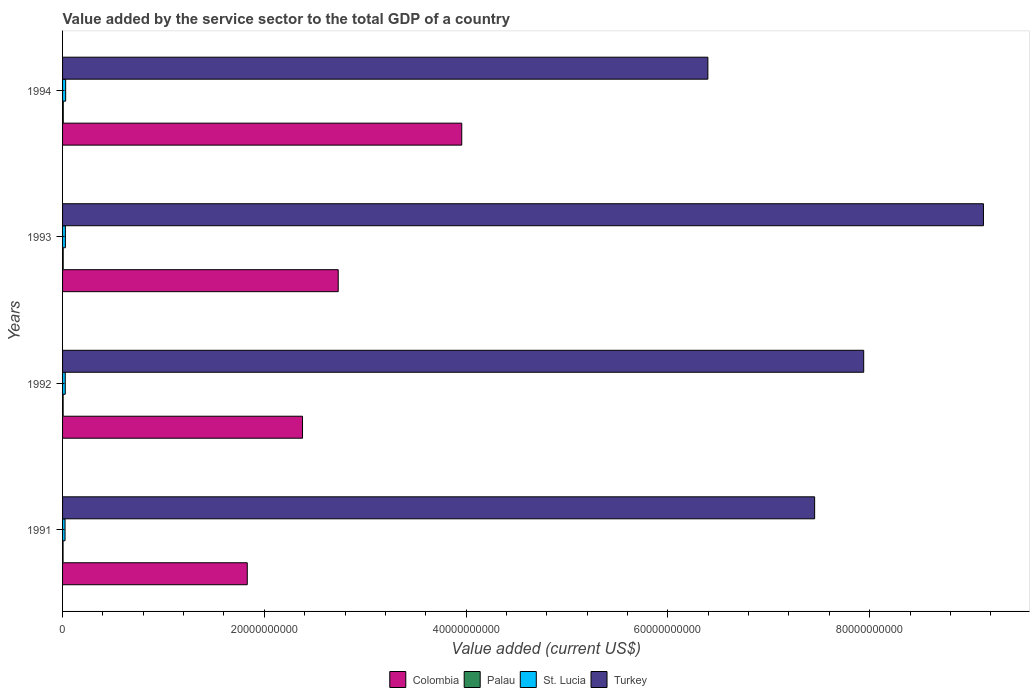How many different coloured bars are there?
Ensure brevity in your answer.  4. Are the number of bars on each tick of the Y-axis equal?
Give a very brief answer. Yes. How many bars are there on the 3rd tick from the bottom?
Ensure brevity in your answer.  4. What is the label of the 4th group of bars from the top?
Ensure brevity in your answer.  1991. What is the value added by the service sector to the total GDP in Palau in 1992?
Offer a terse response. 5.68e+07. Across all years, what is the maximum value added by the service sector to the total GDP in St. Lucia?
Provide a succinct answer. 3.07e+08. Across all years, what is the minimum value added by the service sector to the total GDP in Colombia?
Your response must be concise. 1.83e+1. In which year was the value added by the service sector to the total GDP in Turkey maximum?
Offer a very short reply. 1993. In which year was the value added by the service sector to the total GDP in Palau minimum?
Offer a terse response. 1991. What is the total value added by the service sector to the total GDP in St. Lucia in the graph?
Give a very brief answer. 1.10e+09. What is the difference between the value added by the service sector to the total GDP in Colombia in 1991 and that in 1992?
Your answer should be compact. -5.48e+09. What is the difference between the value added by the service sector to the total GDP in St. Lucia in 1992 and the value added by the service sector to the total GDP in Palau in 1991?
Offer a very short reply. 2.19e+08. What is the average value added by the service sector to the total GDP in Palau per year?
Give a very brief answer. 5.89e+07. In the year 1992, what is the difference between the value added by the service sector to the total GDP in Palau and value added by the service sector to the total GDP in St. Lucia?
Your response must be concise. -2.11e+08. In how many years, is the value added by the service sector to the total GDP in Colombia greater than 20000000000 US$?
Offer a very short reply. 3. What is the ratio of the value added by the service sector to the total GDP in Colombia in 1992 to that in 1994?
Offer a very short reply. 0.6. Is the difference between the value added by the service sector to the total GDP in Palau in 1992 and 1993 greater than the difference between the value added by the service sector to the total GDP in St. Lucia in 1992 and 1993?
Your answer should be compact. Yes. What is the difference between the highest and the second highest value added by the service sector to the total GDP in St. Lucia?
Your answer should be very brief. 2.66e+07. What is the difference between the highest and the lowest value added by the service sector to the total GDP in Turkey?
Provide a short and direct response. 2.73e+1. Is it the case that in every year, the sum of the value added by the service sector to the total GDP in Colombia and value added by the service sector to the total GDP in Palau is greater than the sum of value added by the service sector to the total GDP in St. Lucia and value added by the service sector to the total GDP in Turkey?
Offer a very short reply. Yes. What does the 1st bar from the top in 1994 represents?
Your answer should be very brief. Turkey. What does the 2nd bar from the bottom in 1991 represents?
Keep it short and to the point. Palau. Is it the case that in every year, the sum of the value added by the service sector to the total GDP in St. Lucia and value added by the service sector to the total GDP in Colombia is greater than the value added by the service sector to the total GDP in Turkey?
Make the answer very short. No. Are all the bars in the graph horizontal?
Your response must be concise. Yes. What is the difference between two consecutive major ticks on the X-axis?
Provide a short and direct response. 2.00e+1. Are the values on the major ticks of X-axis written in scientific E-notation?
Offer a very short reply. No. Does the graph contain any zero values?
Provide a short and direct response. No. Where does the legend appear in the graph?
Provide a succinct answer. Bottom center. How many legend labels are there?
Give a very brief answer. 4. What is the title of the graph?
Keep it short and to the point. Value added by the service sector to the total GDP of a country. Does "Iran" appear as one of the legend labels in the graph?
Your answer should be very brief. No. What is the label or title of the X-axis?
Offer a very short reply. Value added (current US$). What is the Value added (current US$) in Colombia in 1991?
Offer a terse response. 1.83e+1. What is the Value added (current US$) of Palau in 1991?
Your response must be concise. 4.89e+07. What is the Value added (current US$) of St. Lucia in 1991?
Your answer should be very brief. 2.46e+08. What is the Value added (current US$) of Turkey in 1991?
Give a very brief answer. 7.45e+1. What is the Value added (current US$) of Colombia in 1992?
Your answer should be very brief. 2.38e+1. What is the Value added (current US$) in Palau in 1992?
Your response must be concise. 5.68e+07. What is the Value added (current US$) of St. Lucia in 1992?
Provide a succinct answer. 2.68e+08. What is the Value added (current US$) in Turkey in 1992?
Provide a succinct answer. 7.94e+1. What is the Value added (current US$) of Colombia in 1993?
Your answer should be compact. 2.73e+1. What is the Value added (current US$) in Palau in 1993?
Keep it short and to the point. 6.12e+07. What is the Value added (current US$) of St. Lucia in 1993?
Your response must be concise. 2.80e+08. What is the Value added (current US$) in Turkey in 1993?
Provide a succinct answer. 9.13e+1. What is the Value added (current US$) of Colombia in 1994?
Make the answer very short. 3.96e+1. What is the Value added (current US$) of Palau in 1994?
Offer a very short reply. 6.86e+07. What is the Value added (current US$) of St. Lucia in 1994?
Your answer should be very brief. 3.07e+08. What is the Value added (current US$) of Turkey in 1994?
Provide a short and direct response. 6.40e+1. Across all years, what is the maximum Value added (current US$) of Colombia?
Keep it short and to the point. 3.96e+1. Across all years, what is the maximum Value added (current US$) in Palau?
Your answer should be very brief. 6.86e+07. Across all years, what is the maximum Value added (current US$) of St. Lucia?
Give a very brief answer. 3.07e+08. Across all years, what is the maximum Value added (current US$) of Turkey?
Offer a terse response. 9.13e+1. Across all years, what is the minimum Value added (current US$) in Colombia?
Your answer should be very brief. 1.83e+1. Across all years, what is the minimum Value added (current US$) of Palau?
Provide a succinct answer. 4.89e+07. Across all years, what is the minimum Value added (current US$) of St. Lucia?
Provide a succinct answer. 2.46e+08. Across all years, what is the minimum Value added (current US$) in Turkey?
Offer a very short reply. 6.40e+1. What is the total Value added (current US$) of Colombia in the graph?
Provide a short and direct response. 1.09e+11. What is the total Value added (current US$) of Palau in the graph?
Offer a very short reply. 2.36e+08. What is the total Value added (current US$) in St. Lucia in the graph?
Offer a terse response. 1.10e+09. What is the total Value added (current US$) in Turkey in the graph?
Ensure brevity in your answer.  3.09e+11. What is the difference between the Value added (current US$) of Colombia in 1991 and that in 1992?
Offer a terse response. -5.48e+09. What is the difference between the Value added (current US$) of Palau in 1991 and that in 1992?
Make the answer very short. -7.90e+06. What is the difference between the Value added (current US$) in St. Lucia in 1991 and that in 1992?
Ensure brevity in your answer.  -2.15e+07. What is the difference between the Value added (current US$) of Turkey in 1991 and that in 1992?
Provide a succinct answer. -4.86e+09. What is the difference between the Value added (current US$) in Colombia in 1991 and that in 1993?
Make the answer very short. -9.01e+09. What is the difference between the Value added (current US$) in Palau in 1991 and that in 1993?
Offer a terse response. -1.23e+07. What is the difference between the Value added (current US$) of St. Lucia in 1991 and that in 1993?
Your answer should be very brief. -3.39e+07. What is the difference between the Value added (current US$) in Turkey in 1991 and that in 1993?
Make the answer very short. -1.67e+1. What is the difference between the Value added (current US$) in Colombia in 1991 and that in 1994?
Keep it short and to the point. -2.13e+1. What is the difference between the Value added (current US$) of Palau in 1991 and that in 1994?
Make the answer very short. -1.97e+07. What is the difference between the Value added (current US$) in St. Lucia in 1991 and that in 1994?
Make the answer very short. -6.05e+07. What is the difference between the Value added (current US$) of Turkey in 1991 and that in 1994?
Give a very brief answer. 1.06e+1. What is the difference between the Value added (current US$) of Colombia in 1992 and that in 1993?
Provide a short and direct response. -3.54e+09. What is the difference between the Value added (current US$) in Palau in 1992 and that in 1993?
Provide a short and direct response. -4.41e+06. What is the difference between the Value added (current US$) in St. Lucia in 1992 and that in 1993?
Keep it short and to the point. -1.24e+07. What is the difference between the Value added (current US$) in Turkey in 1992 and that in 1993?
Keep it short and to the point. -1.19e+1. What is the difference between the Value added (current US$) in Colombia in 1992 and that in 1994?
Your response must be concise. -1.58e+1. What is the difference between the Value added (current US$) of Palau in 1992 and that in 1994?
Your response must be concise. -1.18e+07. What is the difference between the Value added (current US$) in St. Lucia in 1992 and that in 1994?
Your answer should be very brief. -3.90e+07. What is the difference between the Value added (current US$) of Turkey in 1992 and that in 1994?
Provide a short and direct response. 1.54e+1. What is the difference between the Value added (current US$) in Colombia in 1993 and that in 1994?
Offer a terse response. -1.22e+1. What is the difference between the Value added (current US$) of Palau in 1993 and that in 1994?
Keep it short and to the point. -7.42e+06. What is the difference between the Value added (current US$) of St. Lucia in 1993 and that in 1994?
Keep it short and to the point. -2.66e+07. What is the difference between the Value added (current US$) in Turkey in 1993 and that in 1994?
Offer a very short reply. 2.73e+1. What is the difference between the Value added (current US$) in Colombia in 1991 and the Value added (current US$) in Palau in 1992?
Your answer should be very brief. 1.83e+1. What is the difference between the Value added (current US$) in Colombia in 1991 and the Value added (current US$) in St. Lucia in 1992?
Your answer should be compact. 1.80e+1. What is the difference between the Value added (current US$) of Colombia in 1991 and the Value added (current US$) of Turkey in 1992?
Your response must be concise. -6.11e+1. What is the difference between the Value added (current US$) of Palau in 1991 and the Value added (current US$) of St. Lucia in 1992?
Make the answer very short. -2.19e+08. What is the difference between the Value added (current US$) of Palau in 1991 and the Value added (current US$) of Turkey in 1992?
Offer a very short reply. -7.94e+1. What is the difference between the Value added (current US$) of St. Lucia in 1991 and the Value added (current US$) of Turkey in 1992?
Your answer should be very brief. -7.92e+1. What is the difference between the Value added (current US$) in Colombia in 1991 and the Value added (current US$) in Palau in 1993?
Offer a terse response. 1.82e+1. What is the difference between the Value added (current US$) in Colombia in 1991 and the Value added (current US$) in St. Lucia in 1993?
Provide a short and direct response. 1.80e+1. What is the difference between the Value added (current US$) of Colombia in 1991 and the Value added (current US$) of Turkey in 1993?
Your answer should be compact. -7.30e+1. What is the difference between the Value added (current US$) in Palau in 1991 and the Value added (current US$) in St. Lucia in 1993?
Provide a short and direct response. -2.31e+08. What is the difference between the Value added (current US$) in Palau in 1991 and the Value added (current US$) in Turkey in 1993?
Your response must be concise. -9.12e+1. What is the difference between the Value added (current US$) in St. Lucia in 1991 and the Value added (current US$) in Turkey in 1993?
Your answer should be very brief. -9.10e+1. What is the difference between the Value added (current US$) in Colombia in 1991 and the Value added (current US$) in Palau in 1994?
Provide a short and direct response. 1.82e+1. What is the difference between the Value added (current US$) of Colombia in 1991 and the Value added (current US$) of St. Lucia in 1994?
Provide a succinct answer. 1.80e+1. What is the difference between the Value added (current US$) in Colombia in 1991 and the Value added (current US$) in Turkey in 1994?
Keep it short and to the point. -4.57e+1. What is the difference between the Value added (current US$) in Palau in 1991 and the Value added (current US$) in St. Lucia in 1994?
Ensure brevity in your answer.  -2.58e+08. What is the difference between the Value added (current US$) in Palau in 1991 and the Value added (current US$) in Turkey in 1994?
Provide a succinct answer. -6.39e+1. What is the difference between the Value added (current US$) of St. Lucia in 1991 and the Value added (current US$) of Turkey in 1994?
Offer a terse response. -6.37e+1. What is the difference between the Value added (current US$) of Colombia in 1992 and the Value added (current US$) of Palau in 1993?
Offer a very short reply. 2.37e+1. What is the difference between the Value added (current US$) in Colombia in 1992 and the Value added (current US$) in St. Lucia in 1993?
Ensure brevity in your answer.  2.35e+1. What is the difference between the Value added (current US$) of Colombia in 1992 and the Value added (current US$) of Turkey in 1993?
Give a very brief answer. -6.75e+1. What is the difference between the Value added (current US$) in Palau in 1992 and the Value added (current US$) in St. Lucia in 1993?
Make the answer very short. -2.23e+08. What is the difference between the Value added (current US$) in Palau in 1992 and the Value added (current US$) in Turkey in 1993?
Ensure brevity in your answer.  -9.12e+1. What is the difference between the Value added (current US$) of St. Lucia in 1992 and the Value added (current US$) of Turkey in 1993?
Provide a succinct answer. -9.10e+1. What is the difference between the Value added (current US$) in Colombia in 1992 and the Value added (current US$) in Palau in 1994?
Provide a short and direct response. 2.37e+1. What is the difference between the Value added (current US$) of Colombia in 1992 and the Value added (current US$) of St. Lucia in 1994?
Keep it short and to the point. 2.35e+1. What is the difference between the Value added (current US$) of Colombia in 1992 and the Value added (current US$) of Turkey in 1994?
Keep it short and to the point. -4.02e+1. What is the difference between the Value added (current US$) of Palau in 1992 and the Value added (current US$) of St. Lucia in 1994?
Keep it short and to the point. -2.50e+08. What is the difference between the Value added (current US$) of Palau in 1992 and the Value added (current US$) of Turkey in 1994?
Offer a very short reply. -6.39e+1. What is the difference between the Value added (current US$) in St. Lucia in 1992 and the Value added (current US$) in Turkey in 1994?
Provide a succinct answer. -6.37e+1. What is the difference between the Value added (current US$) in Colombia in 1993 and the Value added (current US$) in Palau in 1994?
Offer a terse response. 2.73e+1. What is the difference between the Value added (current US$) in Colombia in 1993 and the Value added (current US$) in St. Lucia in 1994?
Your response must be concise. 2.70e+1. What is the difference between the Value added (current US$) of Colombia in 1993 and the Value added (current US$) of Turkey in 1994?
Make the answer very short. -3.66e+1. What is the difference between the Value added (current US$) of Palau in 1993 and the Value added (current US$) of St. Lucia in 1994?
Your answer should be very brief. -2.45e+08. What is the difference between the Value added (current US$) of Palau in 1993 and the Value added (current US$) of Turkey in 1994?
Make the answer very short. -6.39e+1. What is the difference between the Value added (current US$) in St. Lucia in 1993 and the Value added (current US$) in Turkey in 1994?
Keep it short and to the point. -6.37e+1. What is the average Value added (current US$) of Colombia per year?
Offer a very short reply. 2.72e+1. What is the average Value added (current US$) of Palau per year?
Your response must be concise. 5.89e+07. What is the average Value added (current US$) of St. Lucia per year?
Ensure brevity in your answer.  2.75e+08. What is the average Value added (current US$) in Turkey per year?
Provide a short and direct response. 7.73e+1. In the year 1991, what is the difference between the Value added (current US$) in Colombia and Value added (current US$) in Palau?
Provide a succinct answer. 1.83e+1. In the year 1991, what is the difference between the Value added (current US$) of Colombia and Value added (current US$) of St. Lucia?
Your answer should be very brief. 1.81e+1. In the year 1991, what is the difference between the Value added (current US$) in Colombia and Value added (current US$) in Turkey?
Give a very brief answer. -5.62e+1. In the year 1991, what is the difference between the Value added (current US$) of Palau and Value added (current US$) of St. Lucia?
Provide a short and direct response. -1.97e+08. In the year 1991, what is the difference between the Value added (current US$) in Palau and Value added (current US$) in Turkey?
Your response must be concise. -7.45e+1. In the year 1991, what is the difference between the Value added (current US$) in St. Lucia and Value added (current US$) in Turkey?
Offer a terse response. -7.43e+1. In the year 1992, what is the difference between the Value added (current US$) in Colombia and Value added (current US$) in Palau?
Ensure brevity in your answer.  2.37e+1. In the year 1992, what is the difference between the Value added (current US$) in Colombia and Value added (current US$) in St. Lucia?
Give a very brief answer. 2.35e+1. In the year 1992, what is the difference between the Value added (current US$) of Colombia and Value added (current US$) of Turkey?
Your response must be concise. -5.56e+1. In the year 1992, what is the difference between the Value added (current US$) of Palau and Value added (current US$) of St. Lucia?
Offer a terse response. -2.11e+08. In the year 1992, what is the difference between the Value added (current US$) of Palau and Value added (current US$) of Turkey?
Provide a succinct answer. -7.94e+1. In the year 1992, what is the difference between the Value added (current US$) of St. Lucia and Value added (current US$) of Turkey?
Ensure brevity in your answer.  -7.91e+1. In the year 1993, what is the difference between the Value added (current US$) in Colombia and Value added (current US$) in Palau?
Make the answer very short. 2.73e+1. In the year 1993, what is the difference between the Value added (current US$) in Colombia and Value added (current US$) in St. Lucia?
Provide a succinct answer. 2.70e+1. In the year 1993, what is the difference between the Value added (current US$) of Colombia and Value added (current US$) of Turkey?
Your answer should be very brief. -6.40e+1. In the year 1993, what is the difference between the Value added (current US$) in Palau and Value added (current US$) in St. Lucia?
Ensure brevity in your answer.  -2.19e+08. In the year 1993, what is the difference between the Value added (current US$) in Palau and Value added (current US$) in Turkey?
Your answer should be very brief. -9.12e+1. In the year 1993, what is the difference between the Value added (current US$) in St. Lucia and Value added (current US$) in Turkey?
Your answer should be very brief. -9.10e+1. In the year 1994, what is the difference between the Value added (current US$) of Colombia and Value added (current US$) of Palau?
Keep it short and to the point. 3.95e+1. In the year 1994, what is the difference between the Value added (current US$) in Colombia and Value added (current US$) in St. Lucia?
Provide a succinct answer. 3.93e+1. In the year 1994, what is the difference between the Value added (current US$) of Colombia and Value added (current US$) of Turkey?
Make the answer very short. -2.44e+1. In the year 1994, what is the difference between the Value added (current US$) in Palau and Value added (current US$) in St. Lucia?
Offer a terse response. -2.38e+08. In the year 1994, what is the difference between the Value added (current US$) of Palau and Value added (current US$) of Turkey?
Your answer should be compact. -6.39e+1. In the year 1994, what is the difference between the Value added (current US$) of St. Lucia and Value added (current US$) of Turkey?
Offer a terse response. -6.37e+1. What is the ratio of the Value added (current US$) of Colombia in 1991 to that in 1992?
Offer a very short reply. 0.77. What is the ratio of the Value added (current US$) in Palau in 1991 to that in 1992?
Give a very brief answer. 0.86. What is the ratio of the Value added (current US$) of St. Lucia in 1991 to that in 1992?
Ensure brevity in your answer.  0.92. What is the ratio of the Value added (current US$) of Turkey in 1991 to that in 1992?
Keep it short and to the point. 0.94. What is the ratio of the Value added (current US$) in Colombia in 1991 to that in 1993?
Keep it short and to the point. 0.67. What is the ratio of the Value added (current US$) of Palau in 1991 to that in 1993?
Your answer should be very brief. 0.8. What is the ratio of the Value added (current US$) in St. Lucia in 1991 to that in 1993?
Give a very brief answer. 0.88. What is the ratio of the Value added (current US$) of Turkey in 1991 to that in 1993?
Your response must be concise. 0.82. What is the ratio of the Value added (current US$) in Colombia in 1991 to that in 1994?
Keep it short and to the point. 0.46. What is the ratio of the Value added (current US$) in Palau in 1991 to that in 1994?
Your answer should be compact. 0.71. What is the ratio of the Value added (current US$) in St. Lucia in 1991 to that in 1994?
Provide a short and direct response. 0.8. What is the ratio of the Value added (current US$) in Turkey in 1991 to that in 1994?
Provide a succinct answer. 1.17. What is the ratio of the Value added (current US$) in Colombia in 1992 to that in 1993?
Your answer should be very brief. 0.87. What is the ratio of the Value added (current US$) of Palau in 1992 to that in 1993?
Your answer should be very brief. 0.93. What is the ratio of the Value added (current US$) of St. Lucia in 1992 to that in 1993?
Your response must be concise. 0.96. What is the ratio of the Value added (current US$) in Turkey in 1992 to that in 1993?
Your answer should be very brief. 0.87. What is the ratio of the Value added (current US$) in Colombia in 1992 to that in 1994?
Offer a very short reply. 0.6. What is the ratio of the Value added (current US$) of Palau in 1992 to that in 1994?
Give a very brief answer. 0.83. What is the ratio of the Value added (current US$) of St. Lucia in 1992 to that in 1994?
Provide a short and direct response. 0.87. What is the ratio of the Value added (current US$) in Turkey in 1992 to that in 1994?
Keep it short and to the point. 1.24. What is the ratio of the Value added (current US$) of Colombia in 1993 to that in 1994?
Your answer should be compact. 0.69. What is the ratio of the Value added (current US$) of Palau in 1993 to that in 1994?
Give a very brief answer. 0.89. What is the ratio of the Value added (current US$) in St. Lucia in 1993 to that in 1994?
Your response must be concise. 0.91. What is the ratio of the Value added (current US$) of Turkey in 1993 to that in 1994?
Your response must be concise. 1.43. What is the difference between the highest and the second highest Value added (current US$) in Colombia?
Keep it short and to the point. 1.22e+1. What is the difference between the highest and the second highest Value added (current US$) of Palau?
Offer a very short reply. 7.42e+06. What is the difference between the highest and the second highest Value added (current US$) of St. Lucia?
Keep it short and to the point. 2.66e+07. What is the difference between the highest and the second highest Value added (current US$) in Turkey?
Your answer should be compact. 1.19e+1. What is the difference between the highest and the lowest Value added (current US$) in Colombia?
Offer a very short reply. 2.13e+1. What is the difference between the highest and the lowest Value added (current US$) of Palau?
Ensure brevity in your answer.  1.97e+07. What is the difference between the highest and the lowest Value added (current US$) of St. Lucia?
Your response must be concise. 6.05e+07. What is the difference between the highest and the lowest Value added (current US$) in Turkey?
Your answer should be very brief. 2.73e+1. 